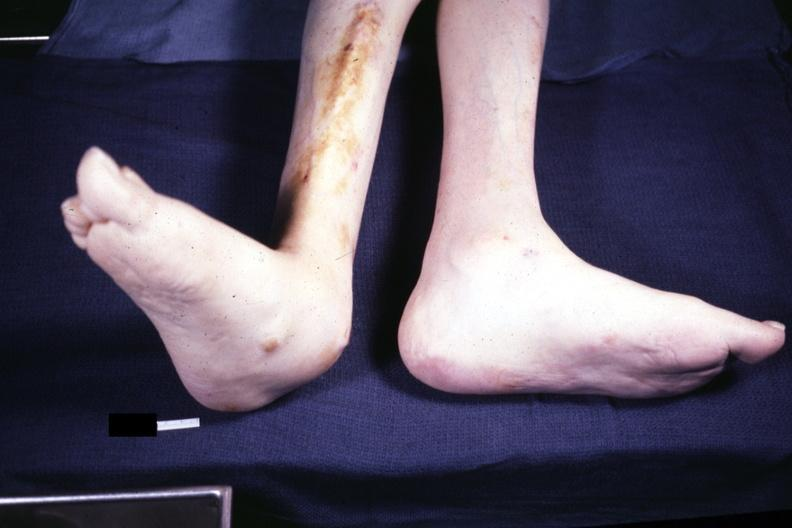what is present?
Answer the question using a single word or phrase. Feet 